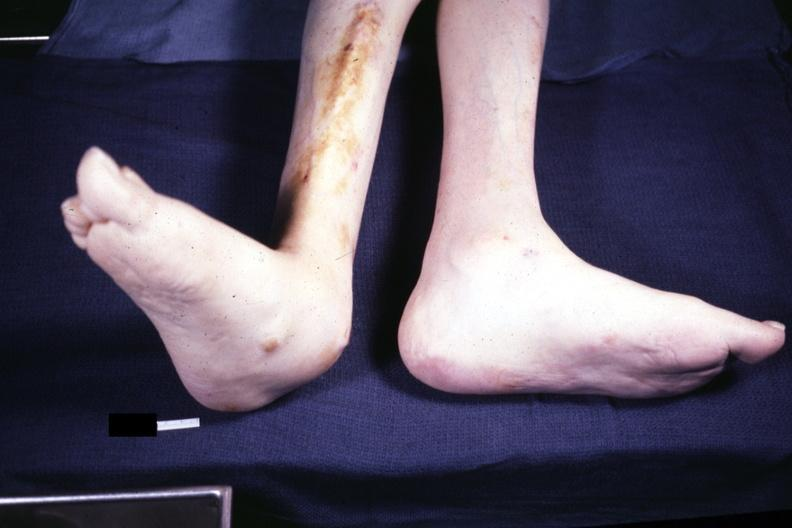what is present?
Answer the question using a single word or phrase. Feet 